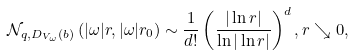Convert formula to latex. <formula><loc_0><loc_0><loc_500><loc_500>\mathcal { N } _ { { q } , D _ { V _ { \omega } } ( b ) } \left ( | \omega | r , | \omega | r _ { 0 } \right ) \sim \frac { 1 } { d ! } \left ( \frac { | \ln r | } { \ln | \ln r | } \right ) ^ { d } , r \searrow 0 ,</formula> 